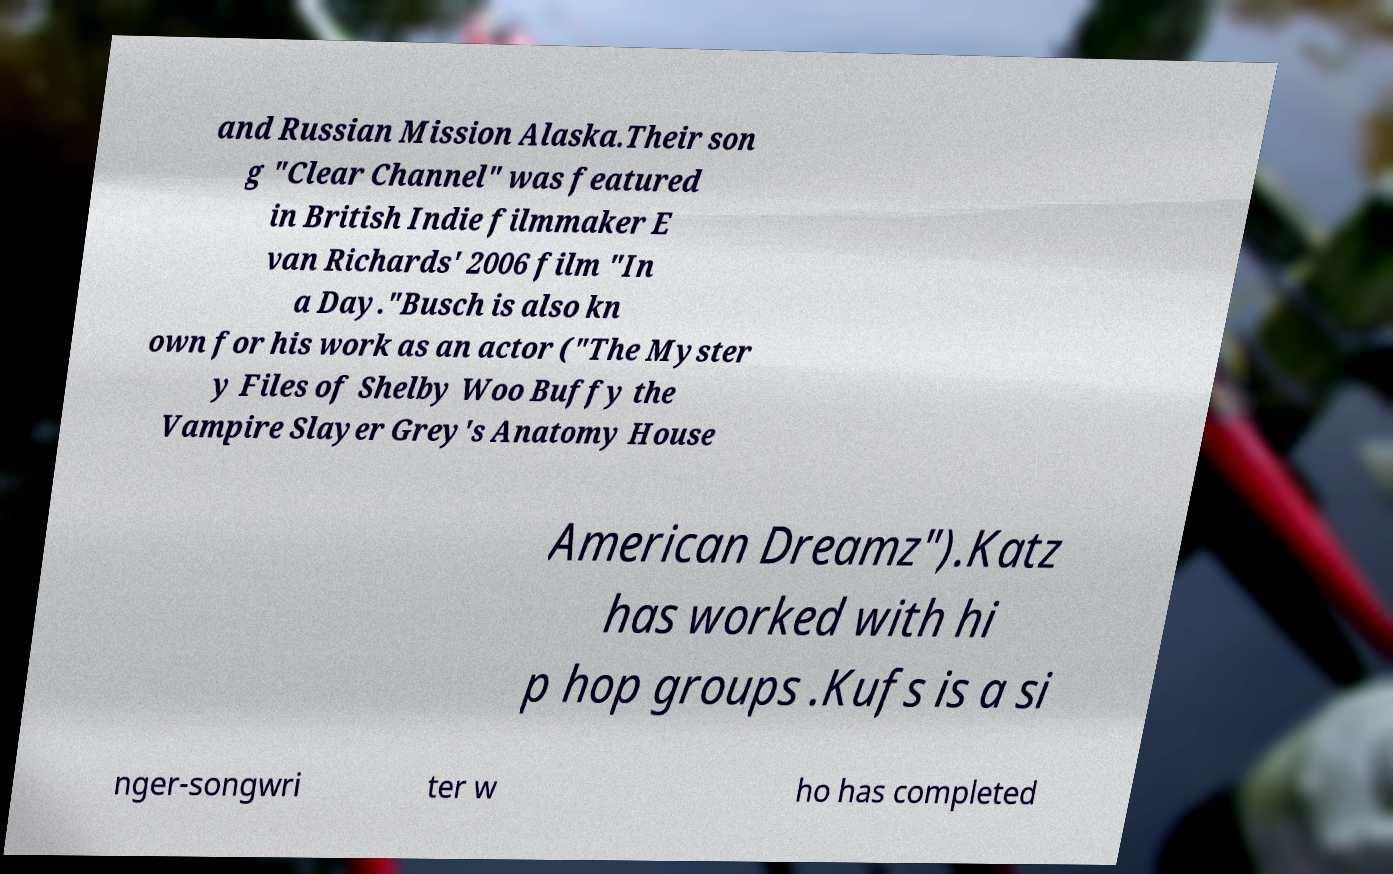I need the written content from this picture converted into text. Can you do that? and Russian Mission Alaska.Their son g "Clear Channel" was featured in British Indie filmmaker E van Richards' 2006 film "In a Day."Busch is also kn own for his work as an actor ("The Myster y Files of Shelby Woo Buffy the Vampire Slayer Grey's Anatomy House American Dreamz").Katz has worked with hi p hop groups .Kufs is a si nger-songwri ter w ho has completed 